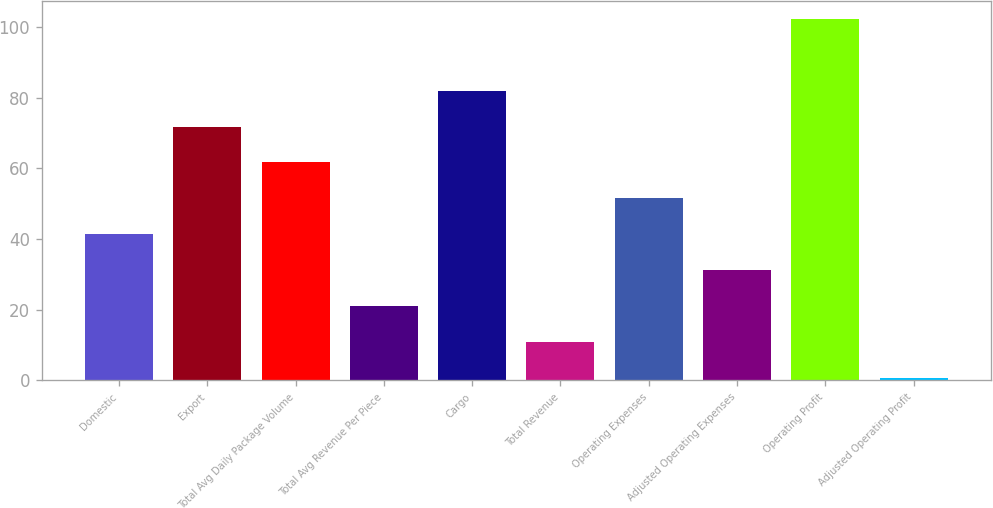Convert chart to OTSL. <chart><loc_0><loc_0><loc_500><loc_500><bar_chart><fcel>Domestic<fcel>Export<fcel>Total Avg Daily Package Volume<fcel>Total Avg Revenue Per Piece<fcel>Cargo<fcel>Total Revenue<fcel>Operating Expenses<fcel>Adjusted Operating Expenses<fcel>Operating Profit<fcel>Adjusted Operating Profit<nl><fcel>41.36<fcel>71.78<fcel>61.64<fcel>21.08<fcel>81.92<fcel>10.94<fcel>51.5<fcel>31.22<fcel>102.2<fcel>0.8<nl></chart> 